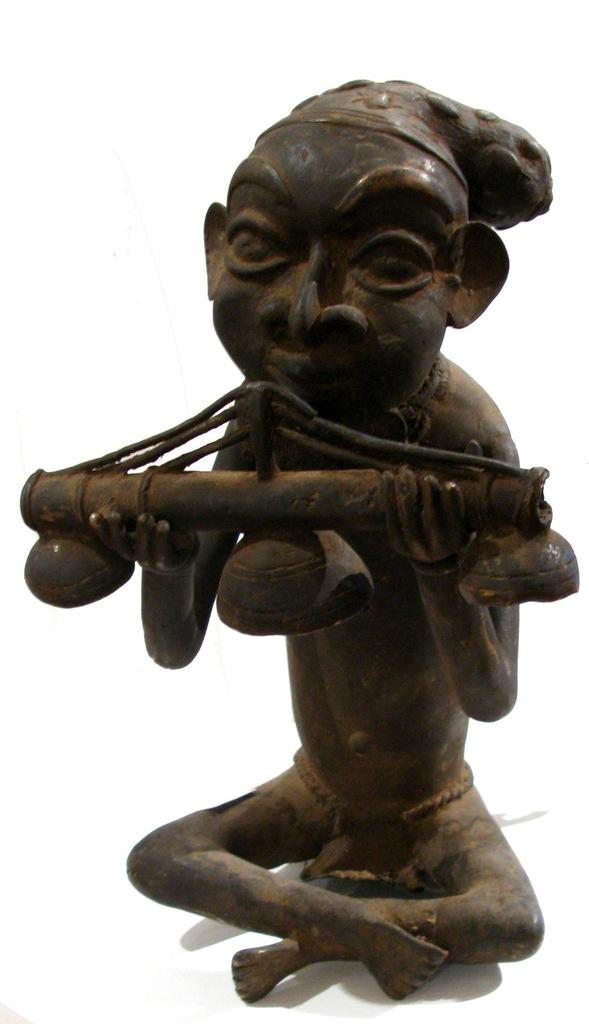What is the main subject of the image? There is a sculpture in the image. What color is the background of the image? The background of the image is white. What type of shop can be seen in the background of the image? There is no shop present in the image; the background is white. 